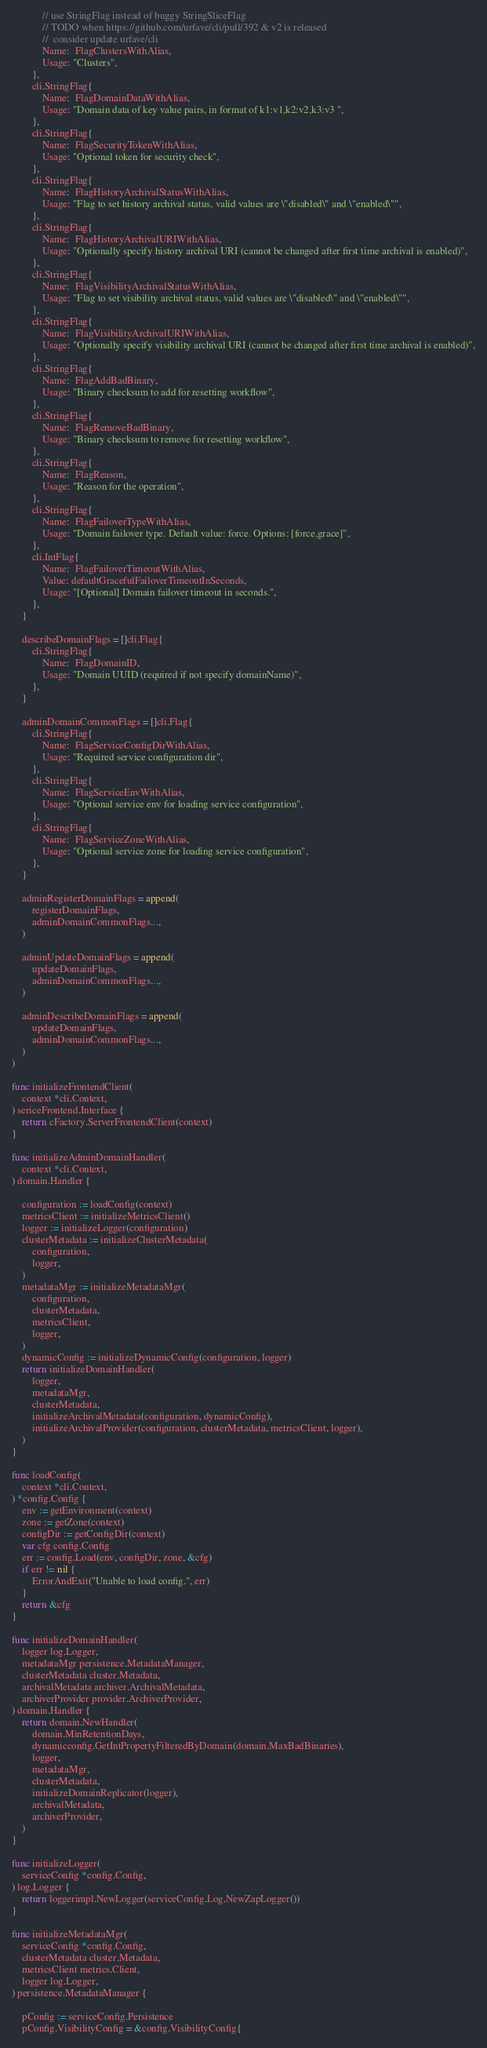Convert code to text. <code><loc_0><loc_0><loc_500><loc_500><_Go_>			// use StringFlag instead of buggy StringSliceFlag
			// TODO when https://github.com/urfave/cli/pull/392 & v2 is released
			//  consider update urfave/cli
			Name:  FlagClustersWithAlias,
			Usage: "Clusters",
		},
		cli.StringFlag{
			Name:  FlagDomainDataWithAlias,
			Usage: "Domain data of key value pairs, in format of k1:v1,k2:v2,k3:v3 ",
		},
		cli.StringFlag{
			Name:  FlagSecurityTokenWithAlias,
			Usage: "Optional token for security check",
		},
		cli.StringFlag{
			Name:  FlagHistoryArchivalStatusWithAlias,
			Usage: "Flag to set history archival status, valid values are \"disabled\" and \"enabled\"",
		},
		cli.StringFlag{
			Name:  FlagHistoryArchivalURIWithAlias,
			Usage: "Optionally specify history archival URI (cannot be changed after first time archival is enabled)",
		},
		cli.StringFlag{
			Name:  FlagVisibilityArchivalStatusWithAlias,
			Usage: "Flag to set visibility archival status, valid values are \"disabled\" and \"enabled\"",
		},
		cli.StringFlag{
			Name:  FlagVisibilityArchivalURIWithAlias,
			Usage: "Optionally specify visibility archival URI (cannot be changed after first time archival is enabled)",
		},
		cli.StringFlag{
			Name:  FlagAddBadBinary,
			Usage: "Binary checksum to add for resetting workflow",
		},
		cli.StringFlag{
			Name:  FlagRemoveBadBinary,
			Usage: "Binary checksum to remove for resetting workflow",
		},
		cli.StringFlag{
			Name:  FlagReason,
			Usage: "Reason for the operation",
		},
		cli.StringFlag{
			Name:  FlagFailoverTypeWithAlias,
			Usage: "Domain failover type. Default value: force. Options: [force,grace]",
		},
		cli.IntFlag{
			Name:  FlagFailoverTimeoutWithAlias,
			Value: defaultGracefulFailoverTimeoutInSeconds,
			Usage: "[Optional] Domain failover timeout in seconds.",
		},
	}

	describeDomainFlags = []cli.Flag{
		cli.StringFlag{
			Name:  FlagDomainID,
			Usage: "Domain UUID (required if not specify domainName)",
		},
	}

	adminDomainCommonFlags = []cli.Flag{
		cli.StringFlag{
			Name:  FlagServiceConfigDirWithAlias,
			Usage: "Required service configuration dir",
		},
		cli.StringFlag{
			Name:  FlagServiceEnvWithAlias,
			Usage: "Optional service env for loading service configuration",
		},
		cli.StringFlag{
			Name:  FlagServiceZoneWithAlias,
			Usage: "Optional service zone for loading service configuration",
		},
	}

	adminRegisterDomainFlags = append(
		registerDomainFlags,
		adminDomainCommonFlags...,
	)

	adminUpdateDomainFlags = append(
		updateDomainFlags,
		adminDomainCommonFlags...,
	)

	adminDescribeDomainFlags = append(
		updateDomainFlags,
		adminDomainCommonFlags...,
	)
)

func initializeFrontendClient(
	context *cli.Context,
) sericeFrontend.Interface {
	return cFactory.ServerFrontendClient(context)
}

func initializeAdminDomainHandler(
	context *cli.Context,
) domain.Handler {

	configuration := loadConfig(context)
	metricsClient := initializeMetricsClient()
	logger := initializeLogger(configuration)
	clusterMetadata := initializeClusterMetadata(
		configuration,
		logger,
	)
	metadataMgr := initializeMetadataMgr(
		configuration,
		clusterMetadata,
		metricsClient,
		logger,
	)
	dynamicConfig := initializeDynamicConfig(configuration, logger)
	return initializeDomainHandler(
		logger,
		metadataMgr,
		clusterMetadata,
		initializeArchivalMetadata(configuration, dynamicConfig),
		initializeArchivalProvider(configuration, clusterMetadata, metricsClient, logger),
	)
}

func loadConfig(
	context *cli.Context,
) *config.Config {
	env := getEnvironment(context)
	zone := getZone(context)
	configDir := getConfigDir(context)
	var cfg config.Config
	err := config.Load(env, configDir, zone, &cfg)
	if err != nil {
		ErrorAndExit("Unable to load config.", err)
	}
	return &cfg
}

func initializeDomainHandler(
	logger log.Logger,
	metadataMgr persistence.MetadataManager,
	clusterMetadata cluster.Metadata,
	archivalMetadata archiver.ArchivalMetadata,
	archiverProvider provider.ArchiverProvider,
) domain.Handler {
	return domain.NewHandler(
		domain.MinRetentionDays,
		dynamicconfig.GetIntPropertyFilteredByDomain(domain.MaxBadBinaries),
		logger,
		metadataMgr,
		clusterMetadata,
		initializeDomainReplicator(logger),
		archivalMetadata,
		archiverProvider,
	)
}

func initializeLogger(
	serviceConfig *config.Config,
) log.Logger {
	return loggerimpl.NewLogger(serviceConfig.Log.NewZapLogger())
}

func initializeMetadataMgr(
	serviceConfig *config.Config,
	clusterMetadata cluster.Metadata,
	metricsClient metrics.Client,
	logger log.Logger,
) persistence.MetadataManager {

	pConfig := serviceConfig.Persistence
	pConfig.VisibilityConfig = &config.VisibilityConfig{</code> 